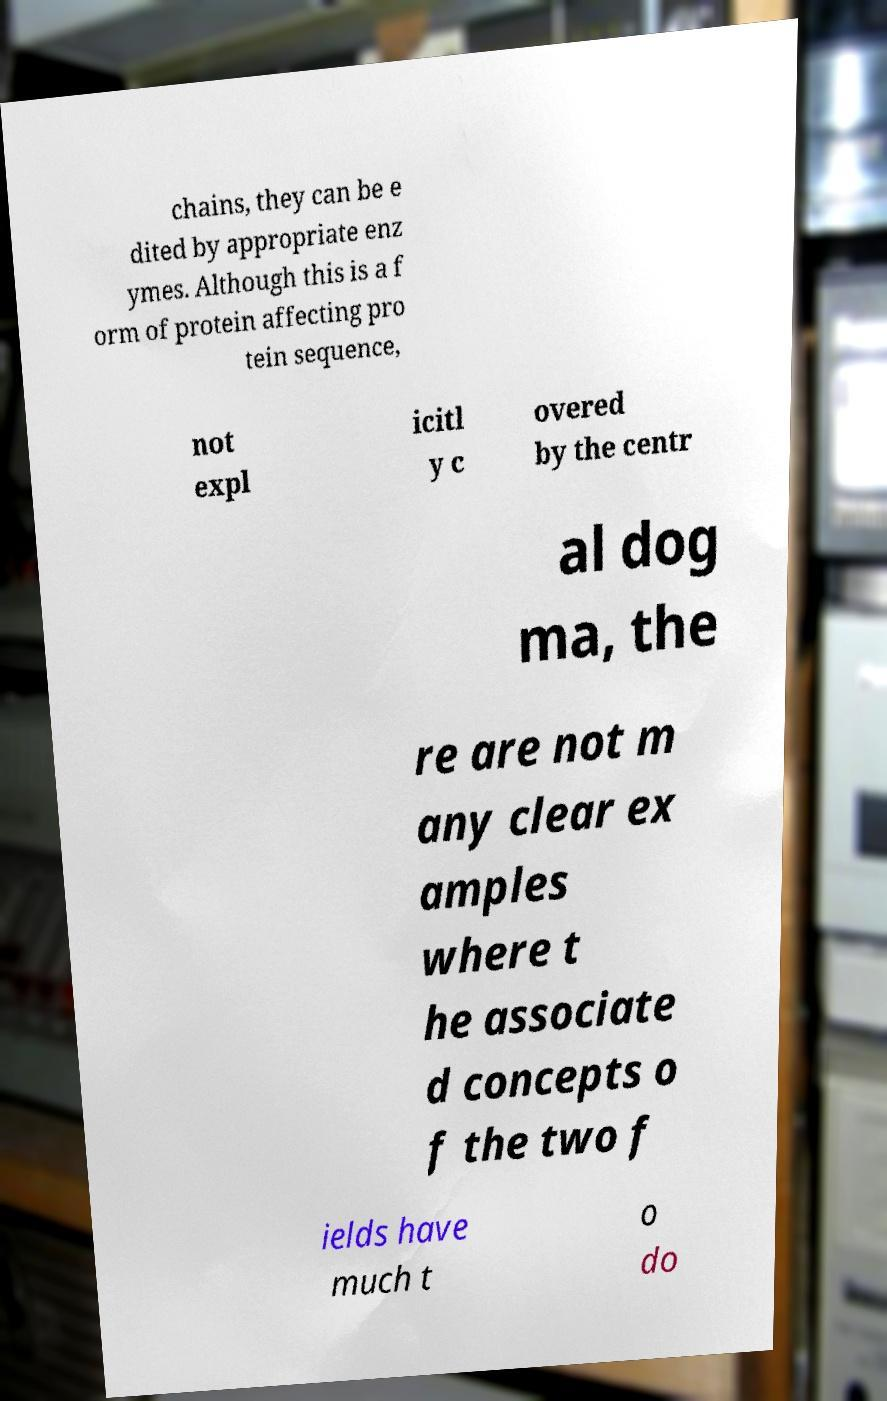Please read and relay the text visible in this image. What does it say? chains, they can be e dited by appropriate enz ymes. Although this is a f orm of protein affecting pro tein sequence, not expl icitl y c overed by the centr al dog ma, the re are not m any clear ex amples where t he associate d concepts o f the two f ields have much t o do 